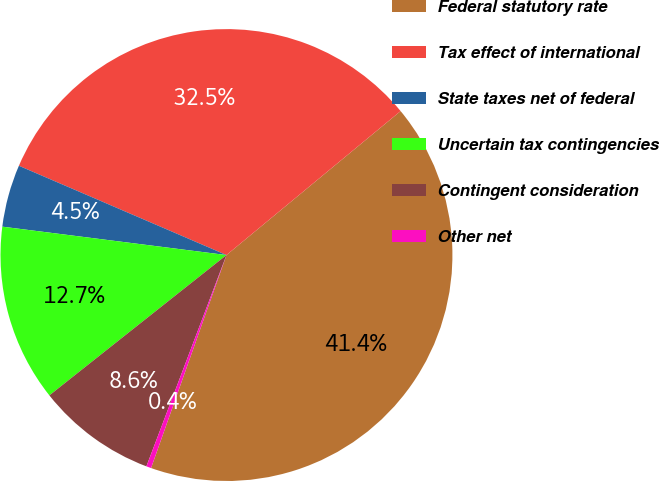Convert chart. <chart><loc_0><loc_0><loc_500><loc_500><pie_chart><fcel>Federal statutory rate<fcel>Tax effect of international<fcel>State taxes net of federal<fcel>Uncertain tax contingencies<fcel>Contingent consideration<fcel>Other net<nl><fcel>41.41%<fcel>32.54%<fcel>4.46%<fcel>12.67%<fcel>8.57%<fcel>0.35%<nl></chart> 